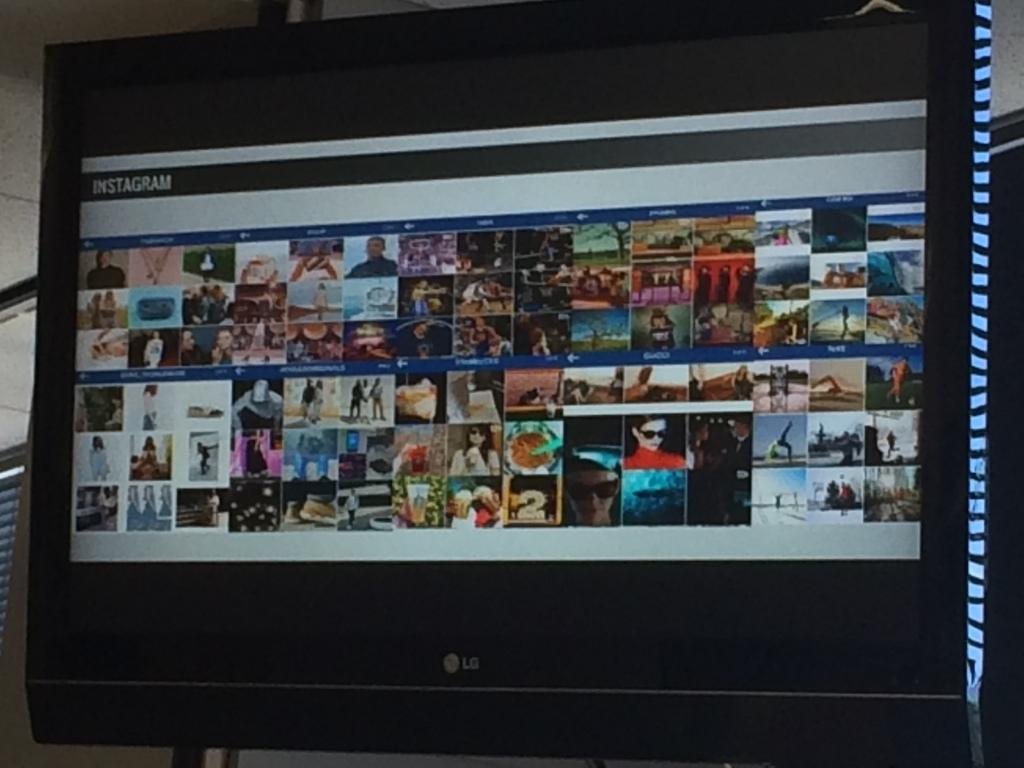<image>
Write a terse but informative summary of the picture. A monitor shows an Instagram page with numerous images on the screen. 